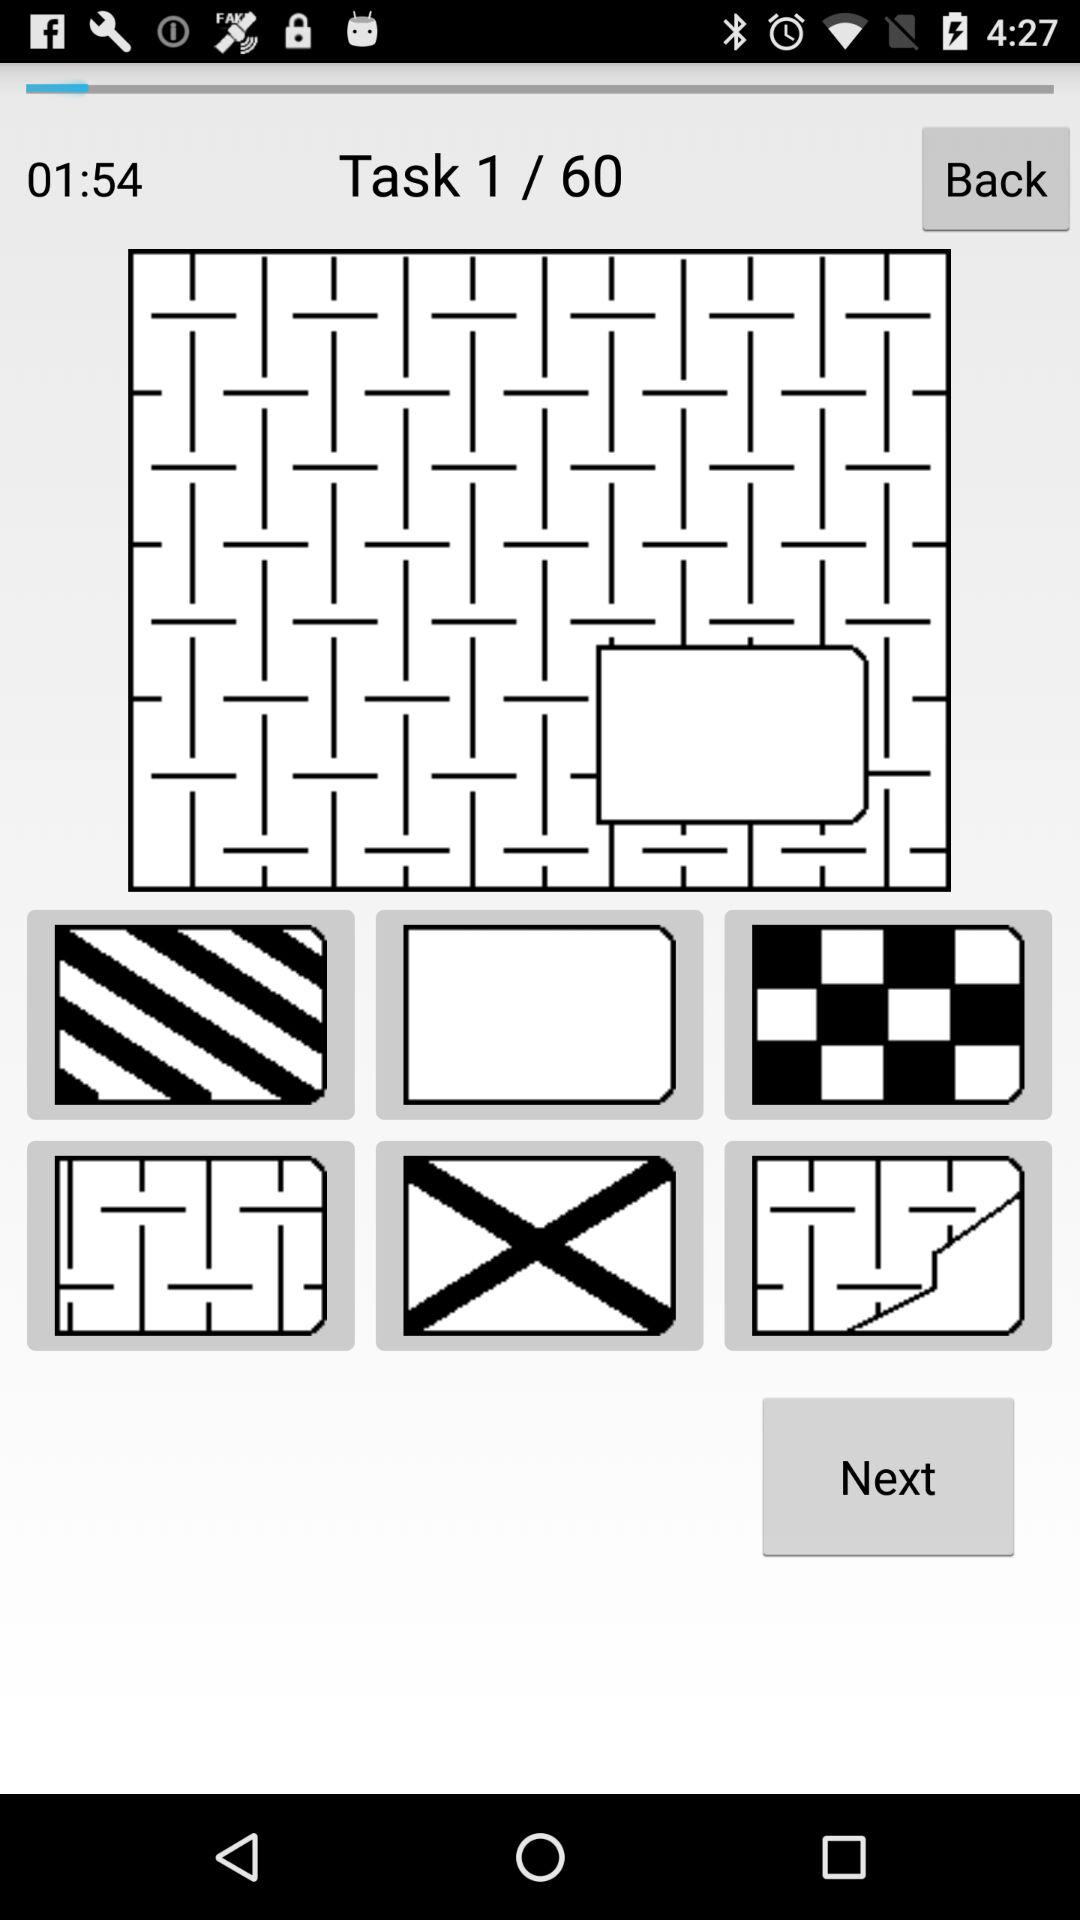On what task is the person currently working? The person is currently working on Task 1. 